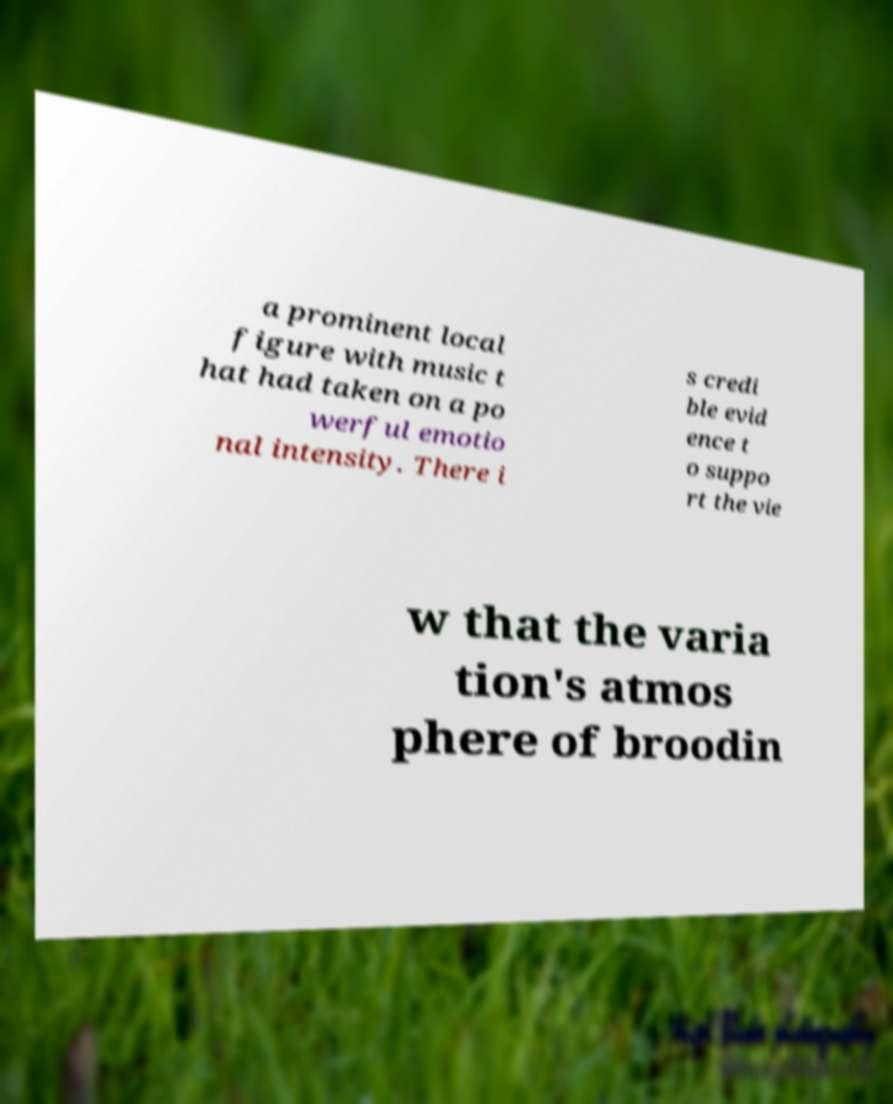What messages or text are displayed in this image? I need them in a readable, typed format. a prominent local figure with music t hat had taken on a po werful emotio nal intensity. There i s credi ble evid ence t o suppo rt the vie w that the varia tion's atmos phere of broodin 